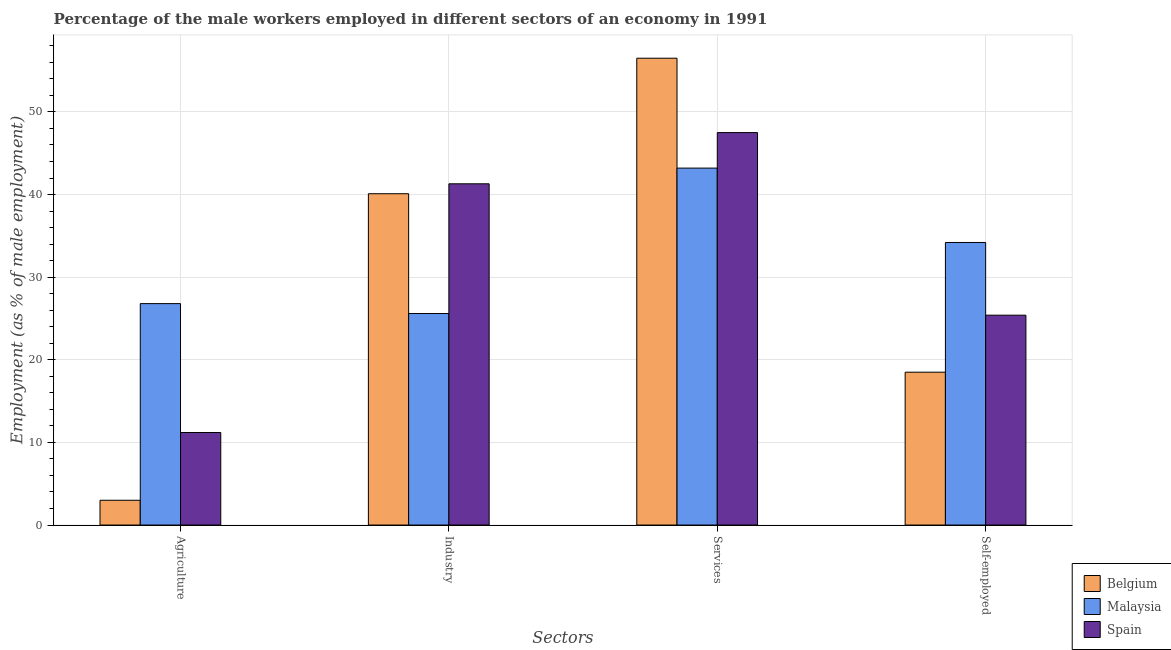How many different coloured bars are there?
Your answer should be compact. 3. Are the number of bars per tick equal to the number of legend labels?
Offer a terse response. Yes. Are the number of bars on each tick of the X-axis equal?
Your response must be concise. Yes. How many bars are there on the 2nd tick from the right?
Your answer should be compact. 3. What is the label of the 2nd group of bars from the left?
Your answer should be compact. Industry. What is the percentage of male workers in industry in Belgium?
Provide a short and direct response. 40.1. Across all countries, what is the maximum percentage of male workers in agriculture?
Give a very brief answer. 26.8. In which country was the percentage of self employed male workers maximum?
Keep it short and to the point. Malaysia. What is the total percentage of male workers in industry in the graph?
Your response must be concise. 107. What is the difference between the percentage of male workers in services in Malaysia and that in Belgium?
Provide a succinct answer. -13.3. What is the difference between the percentage of male workers in agriculture in Belgium and the percentage of male workers in services in Malaysia?
Provide a succinct answer. -40.2. What is the average percentage of self employed male workers per country?
Your answer should be very brief. 26.03. What is the difference between the percentage of male workers in services and percentage of male workers in agriculture in Spain?
Your answer should be compact. 36.3. In how many countries, is the percentage of male workers in agriculture greater than 24 %?
Ensure brevity in your answer.  1. What is the ratio of the percentage of male workers in industry in Spain to that in Belgium?
Provide a short and direct response. 1.03. Is the percentage of self employed male workers in Belgium less than that in Spain?
Provide a short and direct response. Yes. Is the difference between the percentage of male workers in agriculture in Spain and Malaysia greater than the difference between the percentage of self employed male workers in Spain and Malaysia?
Offer a very short reply. No. What is the difference between the highest and the second highest percentage of self employed male workers?
Offer a terse response. 8.8. What is the difference between the highest and the lowest percentage of male workers in services?
Keep it short and to the point. 13.3. In how many countries, is the percentage of male workers in agriculture greater than the average percentage of male workers in agriculture taken over all countries?
Keep it short and to the point. 1. Is it the case that in every country, the sum of the percentage of male workers in industry and percentage of self employed male workers is greater than the sum of percentage of male workers in services and percentage of male workers in agriculture?
Provide a short and direct response. No. What does the 3rd bar from the left in Services represents?
Your answer should be very brief. Spain. What does the 3rd bar from the right in Industry represents?
Your answer should be very brief. Belgium. Is it the case that in every country, the sum of the percentage of male workers in agriculture and percentage of male workers in industry is greater than the percentage of male workers in services?
Your answer should be very brief. No. Does the graph contain grids?
Provide a succinct answer. Yes. Where does the legend appear in the graph?
Offer a very short reply. Bottom right. How many legend labels are there?
Ensure brevity in your answer.  3. What is the title of the graph?
Offer a terse response. Percentage of the male workers employed in different sectors of an economy in 1991. What is the label or title of the X-axis?
Give a very brief answer. Sectors. What is the label or title of the Y-axis?
Your answer should be compact. Employment (as % of male employment). What is the Employment (as % of male employment) of Malaysia in Agriculture?
Your response must be concise. 26.8. What is the Employment (as % of male employment) in Spain in Agriculture?
Provide a succinct answer. 11.2. What is the Employment (as % of male employment) of Belgium in Industry?
Keep it short and to the point. 40.1. What is the Employment (as % of male employment) in Malaysia in Industry?
Provide a succinct answer. 25.6. What is the Employment (as % of male employment) of Spain in Industry?
Your response must be concise. 41.3. What is the Employment (as % of male employment) of Belgium in Services?
Keep it short and to the point. 56.5. What is the Employment (as % of male employment) in Malaysia in Services?
Make the answer very short. 43.2. What is the Employment (as % of male employment) in Spain in Services?
Provide a succinct answer. 47.5. What is the Employment (as % of male employment) of Belgium in Self-employed?
Your answer should be compact. 18.5. What is the Employment (as % of male employment) of Malaysia in Self-employed?
Your answer should be very brief. 34.2. What is the Employment (as % of male employment) in Spain in Self-employed?
Offer a terse response. 25.4. Across all Sectors, what is the maximum Employment (as % of male employment) in Belgium?
Your answer should be compact. 56.5. Across all Sectors, what is the maximum Employment (as % of male employment) of Malaysia?
Ensure brevity in your answer.  43.2. Across all Sectors, what is the maximum Employment (as % of male employment) in Spain?
Give a very brief answer. 47.5. Across all Sectors, what is the minimum Employment (as % of male employment) in Malaysia?
Offer a terse response. 25.6. Across all Sectors, what is the minimum Employment (as % of male employment) in Spain?
Provide a short and direct response. 11.2. What is the total Employment (as % of male employment) of Belgium in the graph?
Offer a terse response. 118.1. What is the total Employment (as % of male employment) in Malaysia in the graph?
Your answer should be very brief. 129.8. What is the total Employment (as % of male employment) in Spain in the graph?
Offer a terse response. 125.4. What is the difference between the Employment (as % of male employment) of Belgium in Agriculture and that in Industry?
Give a very brief answer. -37.1. What is the difference between the Employment (as % of male employment) in Spain in Agriculture and that in Industry?
Provide a short and direct response. -30.1. What is the difference between the Employment (as % of male employment) of Belgium in Agriculture and that in Services?
Offer a terse response. -53.5. What is the difference between the Employment (as % of male employment) of Malaysia in Agriculture and that in Services?
Provide a succinct answer. -16.4. What is the difference between the Employment (as % of male employment) in Spain in Agriculture and that in Services?
Provide a short and direct response. -36.3. What is the difference between the Employment (as % of male employment) in Belgium in Agriculture and that in Self-employed?
Your response must be concise. -15.5. What is the difference between the Employment (as % of male employment) of Malaysia in Agriculture and that in Self-employed?
Your answer should be compact. -7.4. What is the difference between the Employment (as % of male employment) in Spain in Agriculture and that in Self-employed?
Your response must be concise. -14.2. What is the difference between the Employment (as % of male employment) in Belgium in Industry and that in Services?
Ensure brevity in your answer.  -16.4. What is the difference between the Employment (as % of male employment) in Malaysia in Industry and that in Services?
Provide a short and direct response. -17.6. What is the difference between the Employment (as % of male employment) of Belgium in Industry and that in Self-employed?
Ensure brevity in your answer.  21.6. What is the difference between the Employment (as % of male employment) of Malaysia in Industry and that in Self-employed?
Provide a short and direct response. -8.6. What is the difference between the Employment (as % of male employment) of Spain in Industry and that in Self-employed?
Provide a succinct answer. 15.9. What is the difference between the Employment (as % of male employment) in Belgium in Services and that in Self-employed?
Your answer should be compact. 38. What is the difference between the Employment (as % of male employment) in Malaysia in Services and that in Self-employed?
Offer a terse response. 9. What is the difference between the Employment (as % of male employment) of Spain in Services and that in Self-employed?
Your response must be concise. 22.1. What is the difference between the Employment (as % of male employment) in Belgium in Agriculture and the Employment (as % of male employment) in Malaysia in Industry?
Keep it short and to the point. -22.6. What is the difference between the Employment (as % of male employment) in Belgium in Agriculture and the Employment (as % of male employment) in Spain in Industry?
Your answer should be very brief. -38.3. What is the difference between the Employment (as % of male employment) in Malaysia in Agriculture and the Employment (as % of male employment) in Spain in Industry?
Make the answer very short. -14.5. What is the difference between the Employment (as % of male employment) in Belgium in Agriculture and the Employment (as % of male employment) in Malaysia in Services?
Make the answer very short. -40.2. What is the difference between the Employment (as % of male employment) in Belgium in Agriculture and the Employment (as % of male employment) in Spain in Services?
Provide a succinct answer. -44.5. What is the difference between the Employment (as % of male employment) in Malaysia in Agriculture and the Employment (as % of male employment) in Spain in Services?
Give a very brief answer. -20.7. What is the difference between the Employment (as % of male employment) of Belgium in Agriculture and the Employment (as % of male employment) of Malaysia in Self-employed?
Offer a terse response. -31.2. What is the difference between the Employment (as % of male employment) in Belgium in Agriculture and the Employment (as % of male employment) in Spain in Self-employed?
Offer a very short reply. -22.4. What is the difference between the Employment (as % of male employment) in Malaysia in Agriculture and the Employment (as % of male employment) in Spain in Self-employed?
Your response must be concise. 1.4. What is the difference between the Employment (as % of male employment) in Belgium in Industry and the Employment (as % of male employment) in Malaysia in Services?
Offer a very short reply. -3.1. What is the difference between the Employment (as % of male employment) in Belgium in Industry and the Employment (as % of male employment) in Spain in Services?
Ensure brevity in your answer.  -7.4. What is the difference between the Employment (as % of male employment) of Malaysia in Industry and the Employment (as % of male employment) of Spain in Services?
Your answer should be compact. -21.9. What is the difference between the Employment (as % of male employment) of Belgium in Industry and the Employment (as % of male employment) of Malaysia in Self-employed?
Your response must be concise. 5.9. What is the difference between the Employment (as % of male employment) in Belgium in Industry and the Employment (as % of male employment) in Spain in Self-employed?
Your response must be concise. 14.7. What is the difference between the Employment (as % of male employment) of Malaysia in Industry and the Employment (as % of male employment) of Spain in Self-employed?
Your answer should be compact. 0.2. What is the difference between the Employment (as % of male employment) in Belgium in Services and the Employment (as % of male employment) in Malaysia in Self-employed?
Keep it short and to the point. 22.3. What is the difference between the Employment (as % of male employment) in Belgium in Services and the Employment (as % of male employment) in Spain in Self-employed?
Make the answer very short. 31.1. What is the average Employment (as % of male employment) of Belgium per Sectors?
Provide a short and direct response. 29.52. What is the average Employment (as % of male employment) of Malaysia per Sectors?
Make the answer very short. 32.45. What is the average Employment (as % of male employment) in Spain per Sectors?
Ensure brevity in your answer.  31.35. What is the difference between the Employment (as % of male employment) in Belgium and Employment (as % of male employment) in Malaysia in Agriculture?
Give a very brief answer. -23.8. What is the difference between the Employment (as % of male employment) of Belgium and Employment (as % of male employment) of Spain in Agriculture?
Provide a short and direct response. -8.2. What is the difference between the Employment (as % of male employment) of Malaysia and Employment (as % of male employment) of Spain in Agriculture?
Make the answer very short. 15.6. What is the difference between the Employment (as % of male employment) of Malaysia and Employment (as % of male employment) of Spain in Industry?
Your answer should be very brief. -15.7. What is the difference between the Employment (as % of male employment) in Belgium and Employment (as % of male employment) in Malaysia in Services?
Ensure brevity in your answer.  13.3. What is the difference between the Employment (as % of male employment) of Belgium and Employment (as % of male employment) of Spain in Services?
Make the answer very short. 9. What is the difference between the Employment (as % of male employment) in Malaysia and Employment (as % of male employment) in Spain in Services?
Provide a succinct answer. -4.3. What is the difference between the Employment (as % of male employment) of Belgium and Employment (as % of male employment) of Malaysia in Self-employed?
Offer a terse response. -15.7. What is the ratio of the Employment (as % of male employment) of Belgium in Agriculture to that in Industry?
Give a very brief answer. 0.07. What is the ratio of the Employment (as % of male employment) of Malaysia in Agriculture to that in Industry?
Offer a terse response. 1.05. What is the ratio of the Employment (as % of male employment) of Spain in Agriculture to that in Industry?
Offer a terse response. 0.27. What is the ratio of the Employment (as % of male employment) in Belgium in Agriculture to that in Services?
Give a very brief answer. 0.05. What is the ratio of the Employment (as % of male employment) in Malaysia in Agriculture to that in Services?
Your answer should be compact. 0.62. What is the ratio of the Employment (as % of male employment) of Spain in Agriculture to that in Services?
Make the answer very short. 0.24. What is the ratio of the Employment (as % of male employment) in Belgium in Agriculture to that in Self-employed?
Give a very brief answer. 0.16. What is the ratio of the Employment (as % of male employment) in Malaysia in Agriculture to that in Self-employed?
Your answer should be compact. 0.78. What is the ratio of the Employment (as % of male employment) of Spain in Agriculture to that in Self-employed?
Your response must be concise. 0.44. What is the ratio of the Employment (as % of male employment) in Belgium in Industry to that in Services?
Ensure brevity in your answer.  0.71. What is the ratio of the Employment (as % of male employment) in Malaysia in Industry to that in Services?
Your answer should be very brief. 0.59. What is the ratio of the Employment (as % of male employment) in Spain in Industry to that in Services?
Offer a terse response. 0.87. What is the ratio of the Employment (as % of male employment) of Belgium in Industry to that in Self-employed?
Offer a very short reply. 2.17. What is the ratio of the Employment (as % of male employment) in Malaysia in Industry to that in Self-employed?
Offer a very short reply. 0.75. What is the ratio of the Employment (as % of male employment) in Spain in Industry to that in Self-employed?
Offer a terse response. 1.63. What is the ratio of the Employment (as % of male employment) in Belgium in Services to that in Self-employed?
Offer a very short reply. 3.05. What is the ratio of the Employment (as % of male employment) of Malaysia in Services to that in Self-employed?
Your answer should be compact. 1.26. What is the ratio of the Employment (as % of male employment) in Spain in Services to that in Self-employed?
Your answer should be very brief. 1.87. What is the difference between the highest and the second highest Employment (as % of male employment) in Belgium?
Provide a succinct answer. 16.4. What is the difference between the highest and the second highest Employment (as % of male employment) of Malaysia?
Provide a short and direct response. 9. What is the difference between the highest and the second highest Employment (as % of male employment) in Spain?
Give a very brief answer. 6.2. What is the difference between the highest and the lowest Employment (as % of male employment) in Belgium?
Make the answer very short. 53.5. What is the difference between the highest and the lowest Employment (as % of male employment) of Malaysia?
Keep it short and to the point. 17.6. What is the difference between the highest and the lowest Employment (as % of male employment) in Spain?
Keep it short and to the point. 36.3. 